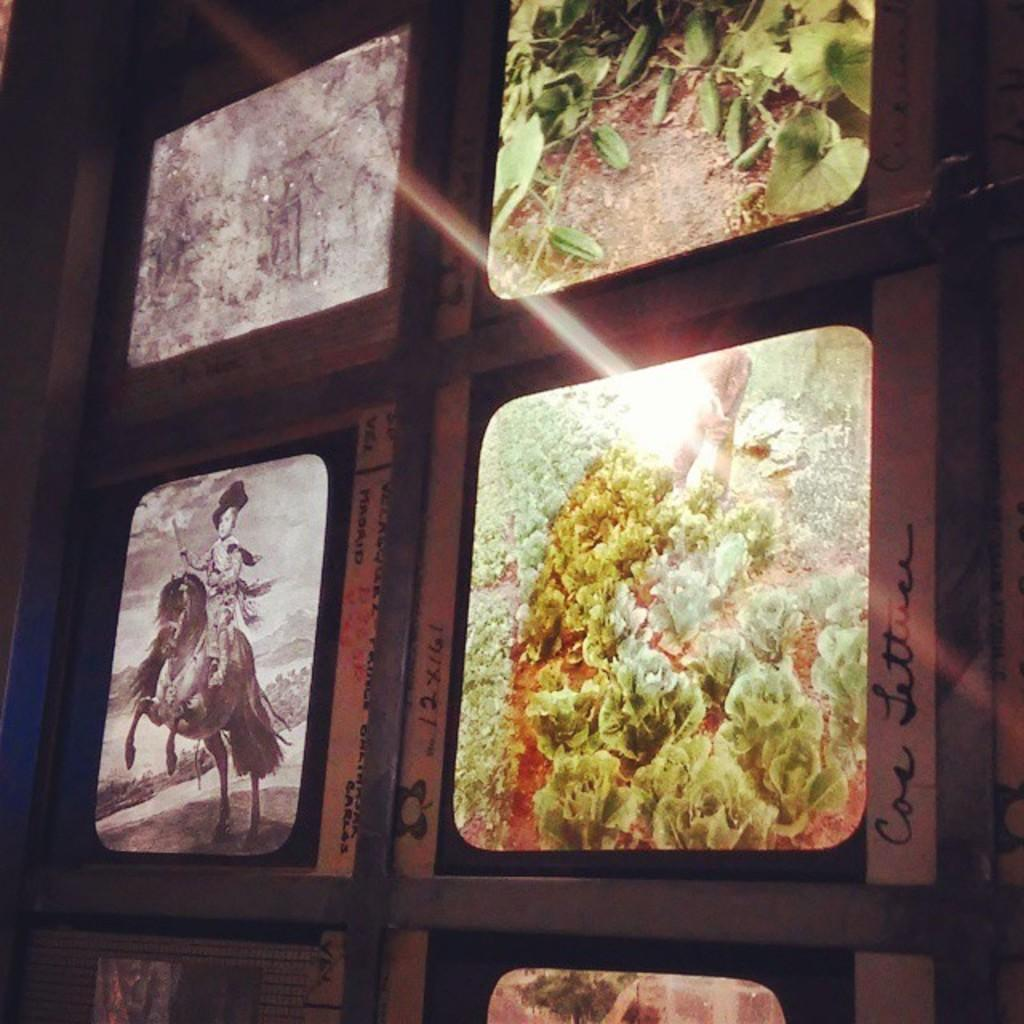What is hanging on the wall in the image? There are photographs on the wall in the image. Can you describe the photographs? The photographs are of different kinds. What else is present on the wall in the image? There is text on the wall in the image. What type of fear can be seen in the photographs on the wall? There is no fear present in the photographs on the wall; they are simply images of different kinds. Is this an office setting, as indicated by the presence of photographs and text on the wall? The image does not provide enough information to determine whether it is an office setting or not. Can you tell me how many scarves are visible in the image? There are no scarves present in the image; it only features photographs and text on the wall. 